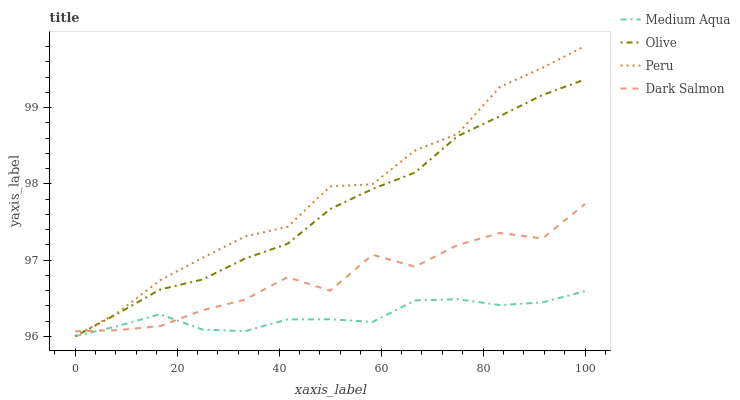Does Dark Salmon have the minimum area under the curve?
Answer yes or no. No. Does Dark Salmon have the maximum area under the curve?
Answer yes or no. No. Is Medium Aqua the smoothest?
Answer yes or no. No. Is Medium Aqua the roughest?
Answer yes or no. No. Does Dark Salmon have the lowest value?
Answer yes or no. No. Does Dark Salmon have the highest value?
Answer yes or no. No. 